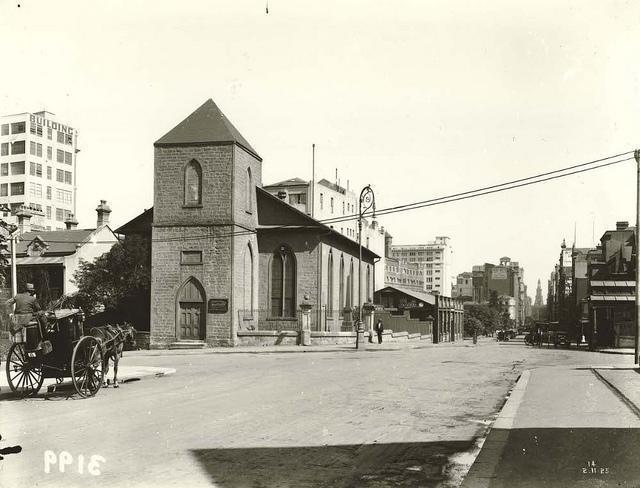How many horses?
Give a very brief answer. 1. How many bears are there?
Give a very brief answer. 0. 